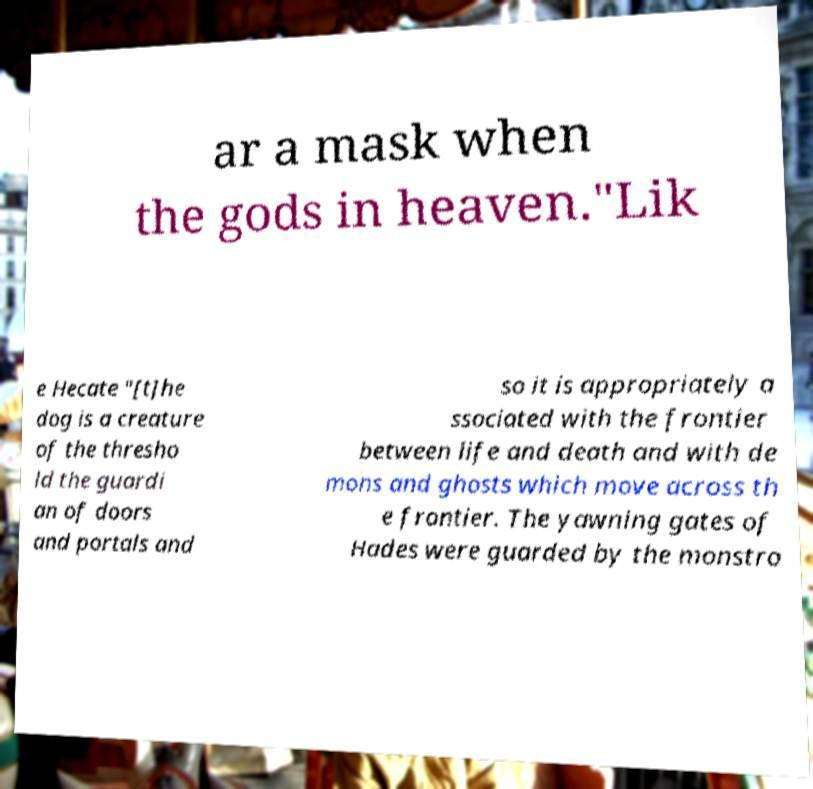For documentation purposes, I need the text within this image transcribed. Could you provide that? ar a mask when the gods in heaven."Lik e Hecate "[t]he dog is a creature of the thresho ld the guardi an of doors and portals and so it is appropriately a ssociated with the frontier between life and death and with de mons and ghosts which move across th e frontier. The yawning gates of Hades were guarded by the monstro 